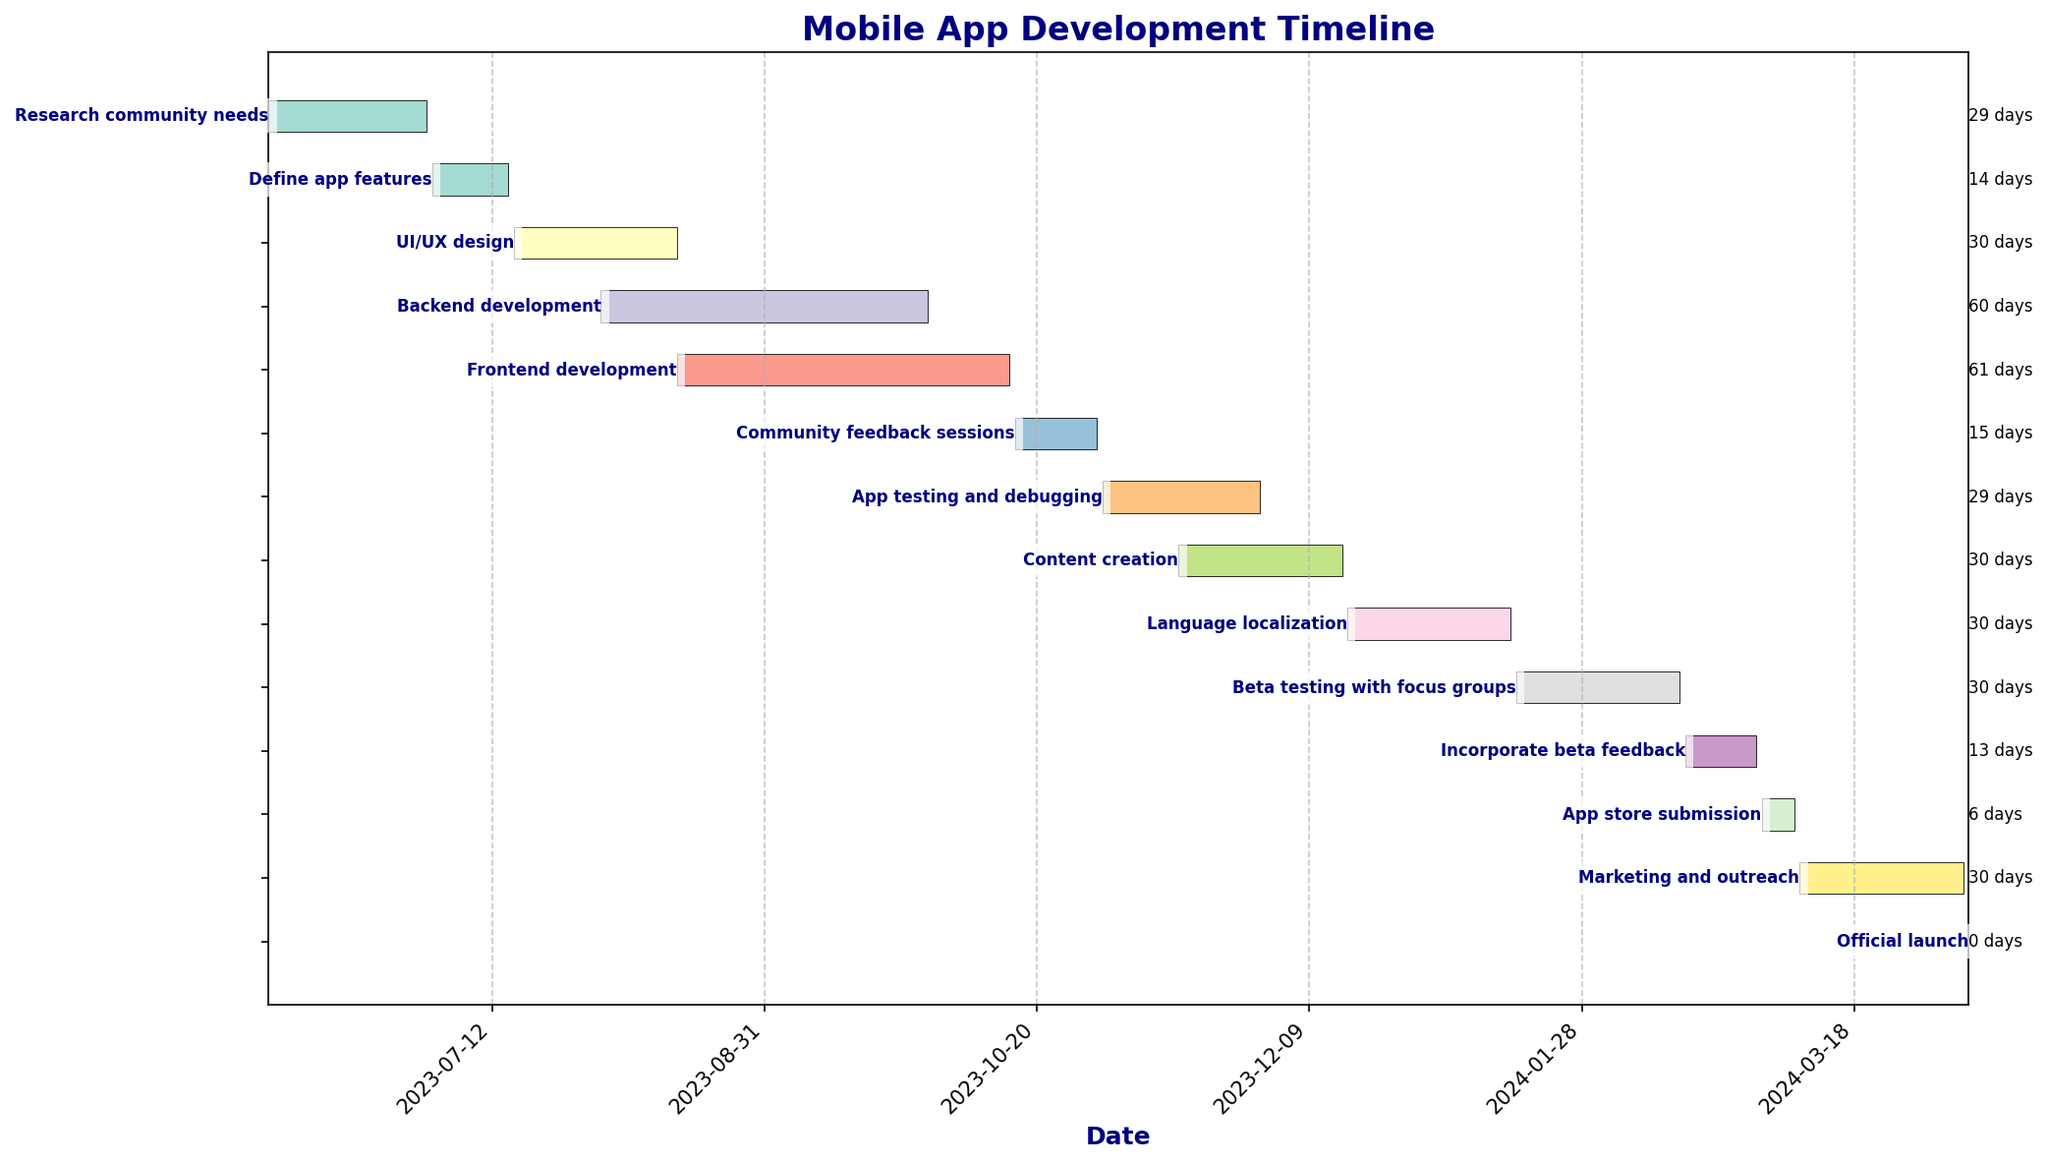What is the title of this Gantt chart? The title is prominently displayed at the top of the chart.
Answer: Mobile App Development Timeline What task has the shortest duration? The chart shows Task durations labeled in days on the right side; the shortest duration is clearly visible as "7 days".
Answer: App store submission How long does the Research community needs phase last? The Research community needs phase's duration is marked next to the task bar.
Answer: 30 days Which task starts immediately after the Research community needs phase ends? The end date of the Research community needs phase is 2023-06-30, and Define app features begins on 2023-07-01, as shown in the timeline.
Answer: Define app features What is the duration of the Backend development task? The duration is visible next to the Backend development task bar.
Answer: 61 days Which tasks overlap with Backend development? By examining the overlapping bars, tasks that share the same timeline are indicated on the chart.
Answer: UI/UX design and Frontend development How many tasks are planned to start in August 2023? Check the start dates of all tasks marked within August 2023.
Answer: Two tasks (Backend development and UI/UX design) Which task follows after the Beta testing with focus groups? The Beta testing with focus groups task ends on 2024-02-15, and Incorporate beta feedback starts on 2024-02-16, as visible on the chart.
Answer: Incorporate beta feedback What is the total duration for the App testing and debugging and Content creation phases combined? Add the durations of App testing and debugging (30 days) and Content creation (31 days).
Answer: 61 days Which two tasks have the same duration? By checking the duration values next to each task, identify two tasks with 31 days each.
Answer: UI/UX design and Content creation 